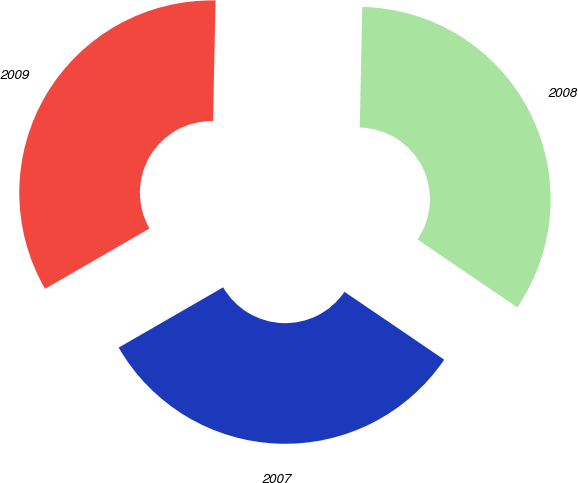<chart> <loc_0><loc_0><loc_500><loc_500><pie_chart><fcel>2009<fcel>2008<fcel>2007<nl><fcel>33.66%<fcel>34.18%<fcel>32.16%<nl></chart> 